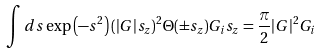Convert formula to latex. <formula><loc_0><loc_0><loc_500><loc_500>\int d { s } \exp \left ( - { s } ^ { 2 } \right ) ( | { G } | s _ { z } ) ^ { 2 } \Theta ( \pm s _ { z } ) G _ { i } s _ { z } = \frac { \pi } { 2 } | { G } | ^ { 2 } G _ { i }</formula> 